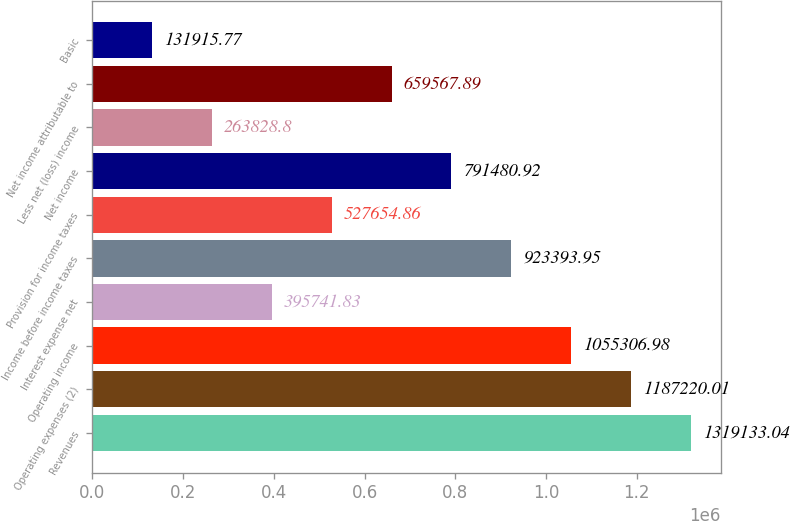Convert chart. <chart><loc_0><loc_0><loc_500><loc_500><bar_chart><fcel>Revenues<fcel>Operating expenses (2)<fcel>Operating income<fcel>Interest expense net<fcel>Income before income taxes<fcel>Provision for income taxes<fcel>Net income<fcel>Less net (loss) income<fcel>Net income attributable to<fcel>Basic<nl><fcel>1.31913e+06<fcel>1.18722e+06<fcel>1.05531e+06<fcel>395742<fcel>923394<fcel>527655<fcel>791481<fcel>263829<fcel>659568<fcel>131916<nl></chart> 